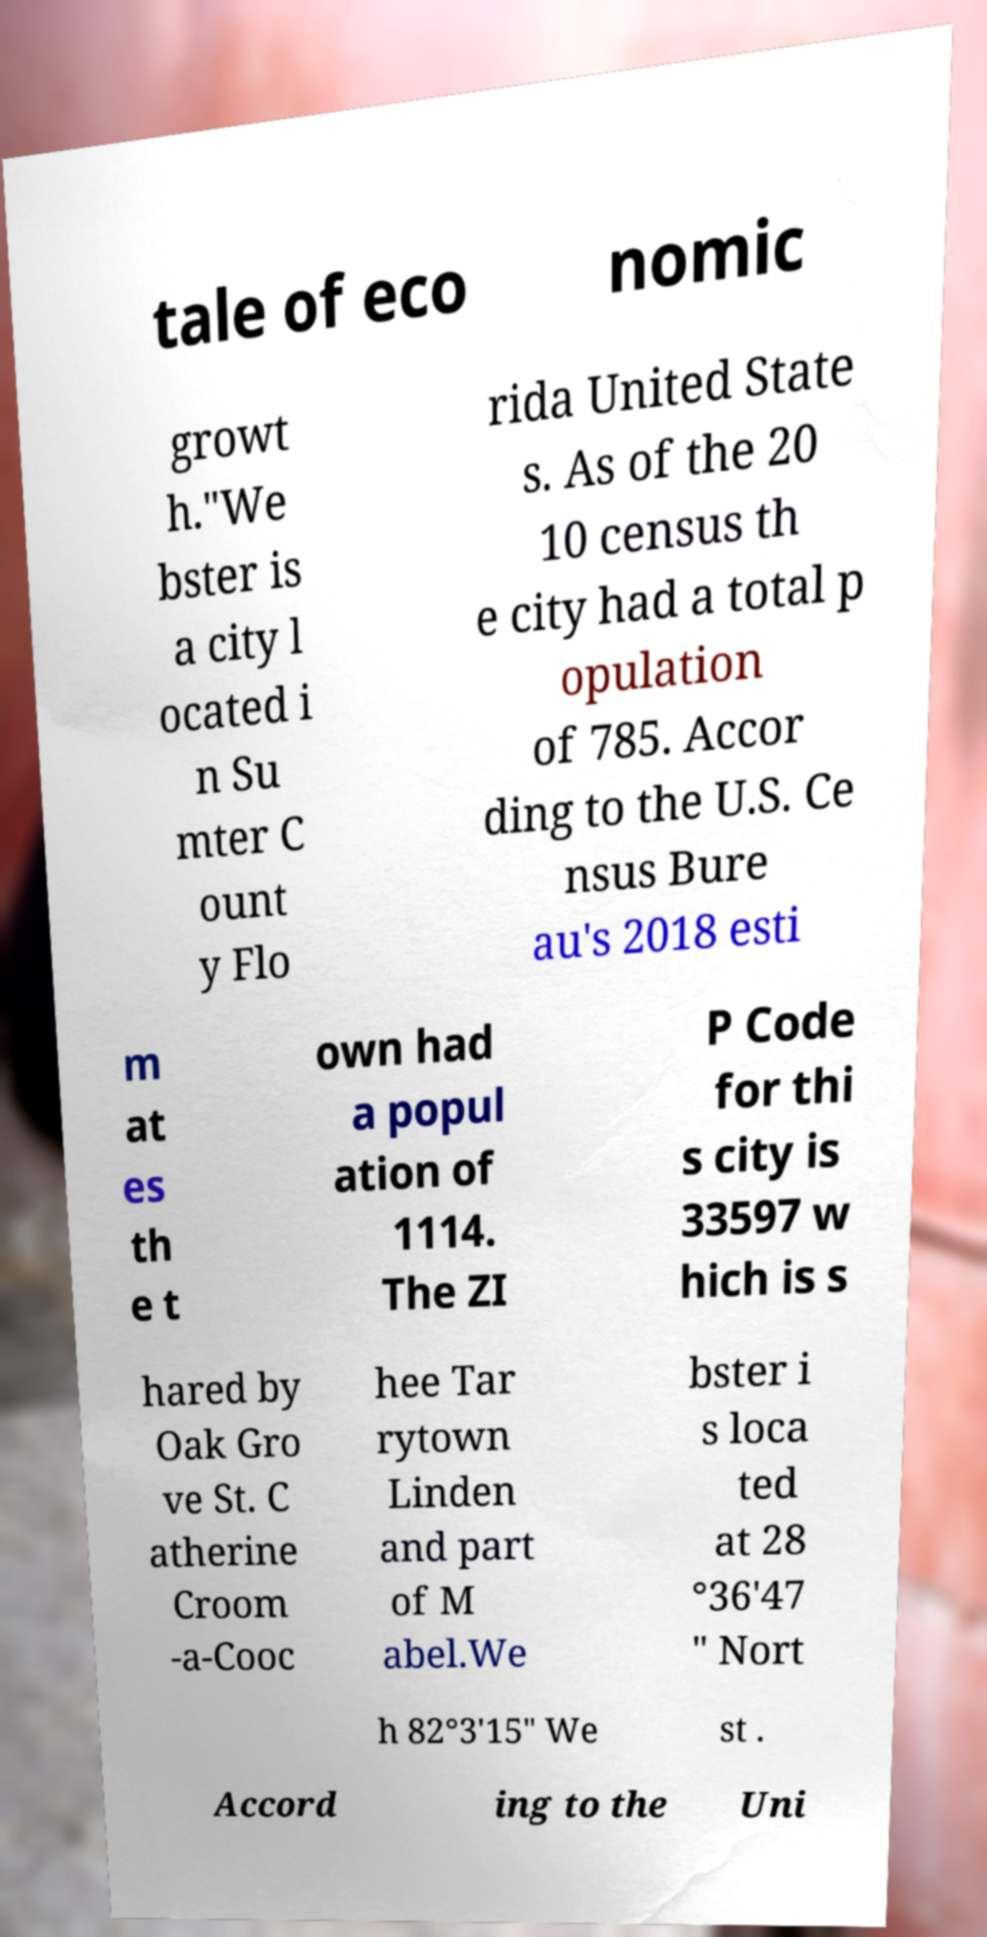Please identify and transcribe the text found in this image. tale of eco nomic growt h."We bster is a city l ocated i n Su mter C ount y Flo rida United State s. As of the 20 10 census th e city had a total p opulation of 785. Accor ding to the U.S. Ce nsus Bure au's 2018 esti m at es th e t own had a popul ation of 1114. The ZI P Code for thi s city is 33597 w hich is s hared by Oak Gro ve St. C atherine Croom -a-Cooc hee Tar rytown Linden and part of M abel.We bster i s loca ted at 28 °36'47 " Nort h 82°3'15" We st . Accord ing to the Uni 